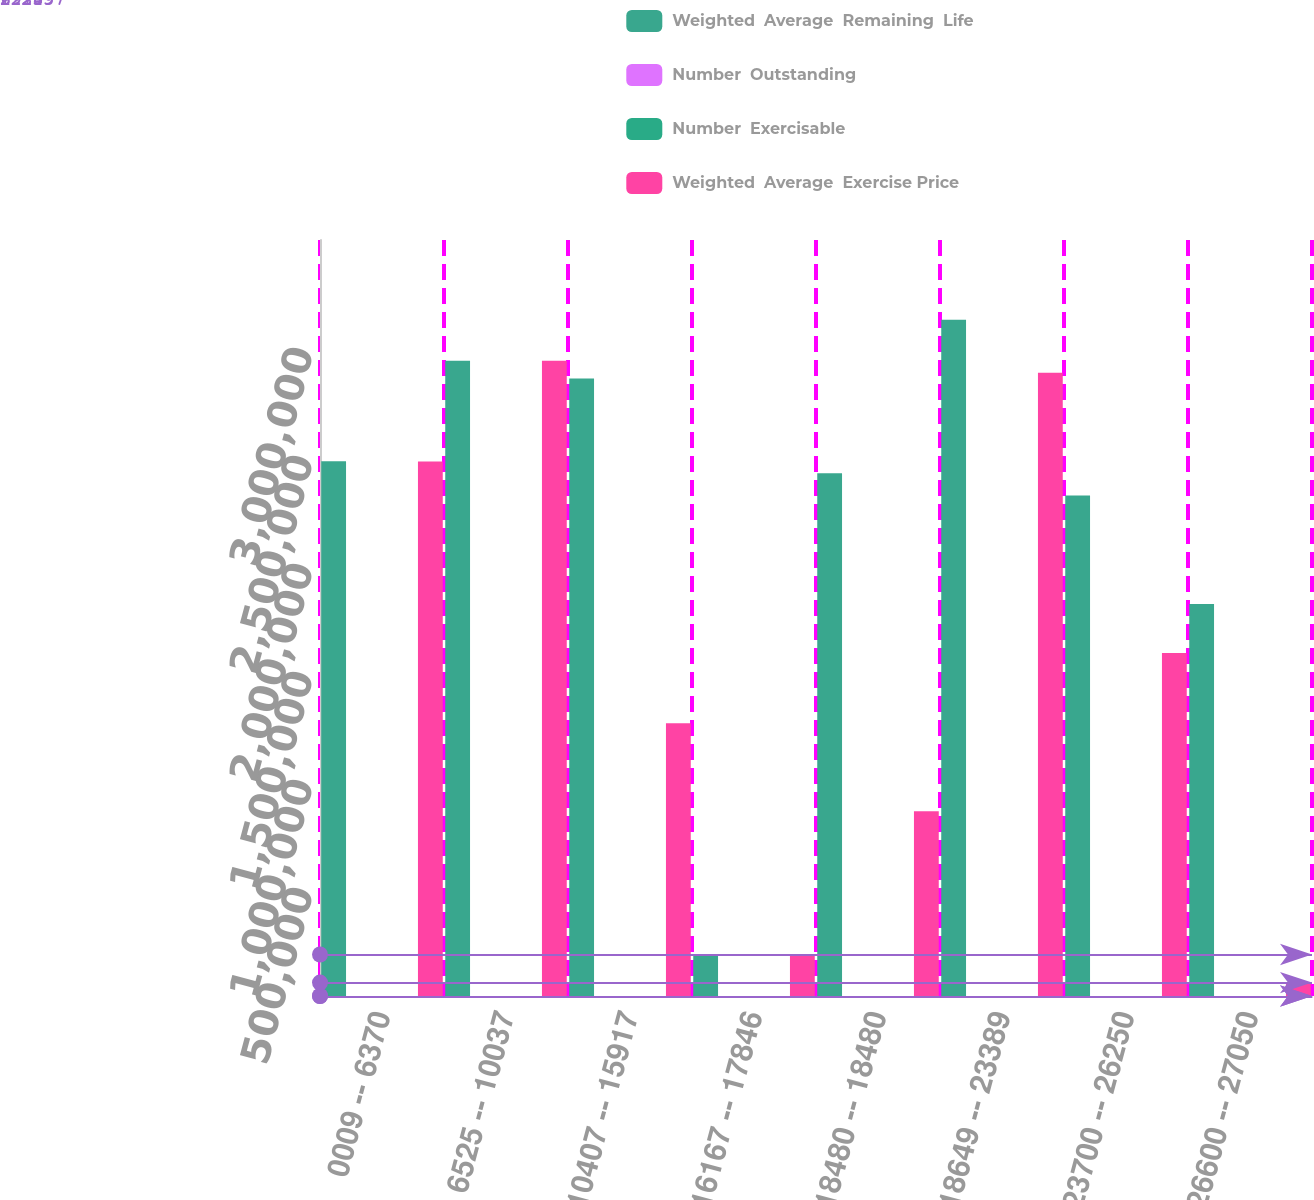Convert chart. <chart><loc_0><loc_0><loc_500><loc_500><stacked_bar_chart><ecel><fcel>0009 -- 6370<fcel>6525 -- 10037<fcel>10407 -- 15917<fcel>16167 -- 17846<fcel>18480 -- 18480<fcel>18649 -- 23389<fcel>23700 -- 26250<fcel>26600 -- 27050<nl><fcel>Weighted  Average  Remaining  Life<fcel>2.4759e+06<fcel>2.94116e+06<fcel>2.85885e+06<fcel>192097<fcel>2.42012e+06<fcel>3.13084e+06<fcel>2.31737e+06<fcel>1.81498e+06<nl><fcel>Number  Outstanding<fcel>2.33<fcel>3.22<fcel>5.81<fcel>5.45<fcel>8.02<fcel>5.57<fcel>7.74<fcel>8.88<nl><fcel>Number  Exercisable<fcel>5.74<fcel>9.3<fcel>15.62<fcel>17.24<fcel>18.48<fcel>22.31<fcel>25.04<fcel>27.04<nl><fcel>Weighted  Average  Exercise Price<fcel>2.47511e+06<fcel>2.94116e+06<fcel>1.26308e+06<fcel>190676<fcel>855142<fcel>2.88507e+06<fcel>1.58815e+06<fcel>62295<nl></chart> 